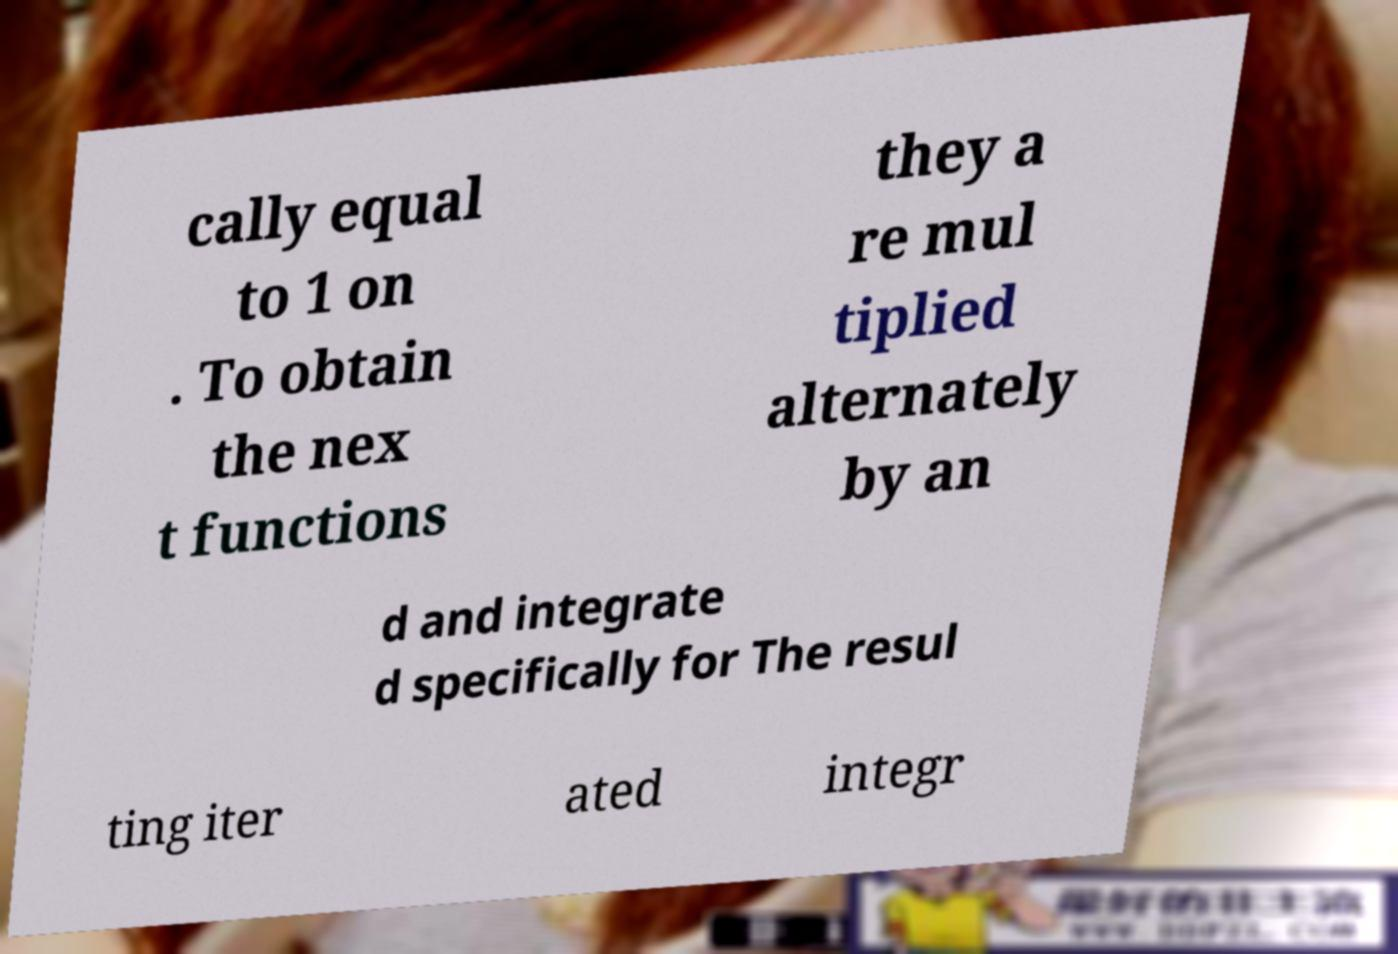Could you extract and type out the text from this image? cally equal to 1 on . To obtain the nex t functions they a re mul tiplied alternately by an d and integrate d specifically for The resul ting iter ated integr 